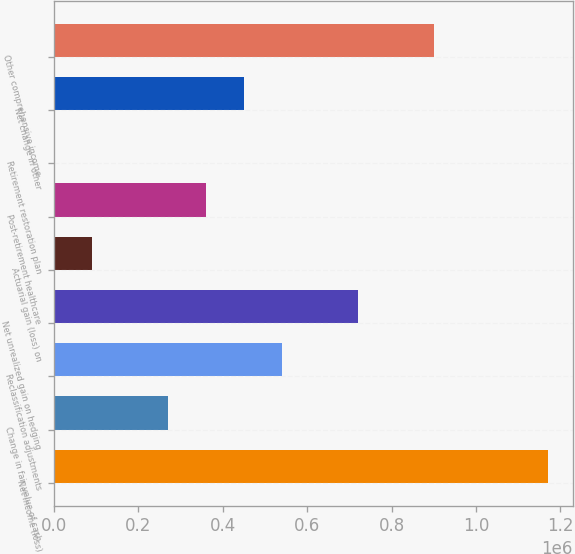Convert chart to OTSL. <chart><loc_0><loc_0><loc_500><loc_500><bar_chart><fcel>Net income (loss)<fcel>Change in fair value of cash<fcel>Reclassification adjustments<fcel>Net unrealized gain on hedging<fcel>Actuarial gain (loss) on<fcel>Post-retirement healthcare<fcel>Retirement restoration plan<fcel>Net change in other<fcel>Other comprehensive income<nl><fcel>1.17088e+06<fcel>270216<fcel>540415<fcel>720547<fcel>90083.3<fcel>360282<fcel>17<fcel>450348<fcel>900680<nl></chart> 